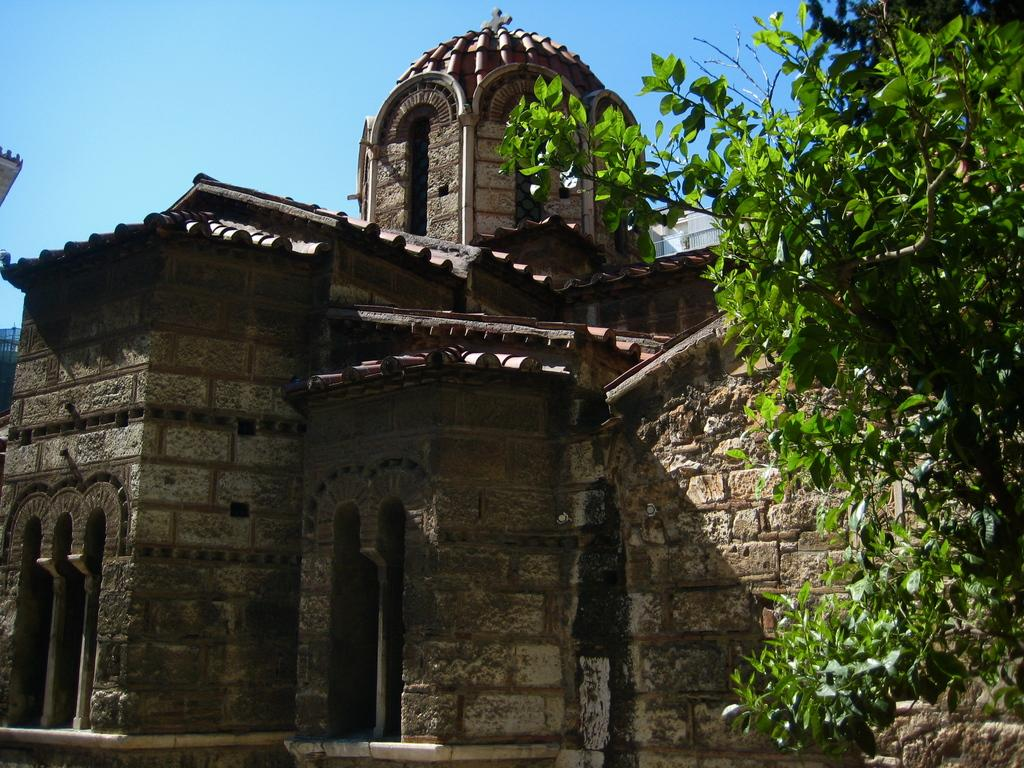What type of vegetation can be seen in the image? There are leaves in the image. What type of structure is present in the image? There is a building in the image. What can be seen in the background of the image? The sky is visible in the background of the image. Can you hear a request being made in the image? There is no sound or indication of a request being made in the image. What type of ear is visible in the image? There is no ear present in the image. 